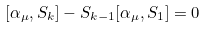Convert formula to latex. <formula><loc_0><loc_0><loc_500><loc_500>[ \alpha _ { \mu } , S _ { k } ] - S _ { k - 1 } [ \alpha _ { \mu } , S _ { 1 } ] = 0</formula> 